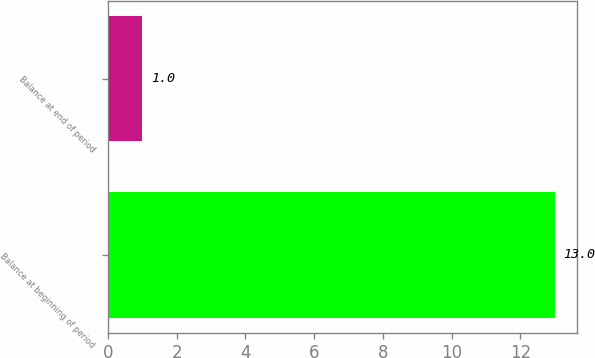Convert chart to OTSL. <chart><loc_0><loc_0><loc_500><loc_500><bar_chart><fcel>Balance at beginning of period<fcel>Balance at end of period<nl><fcel>13<fcel>1<nl></chart> 